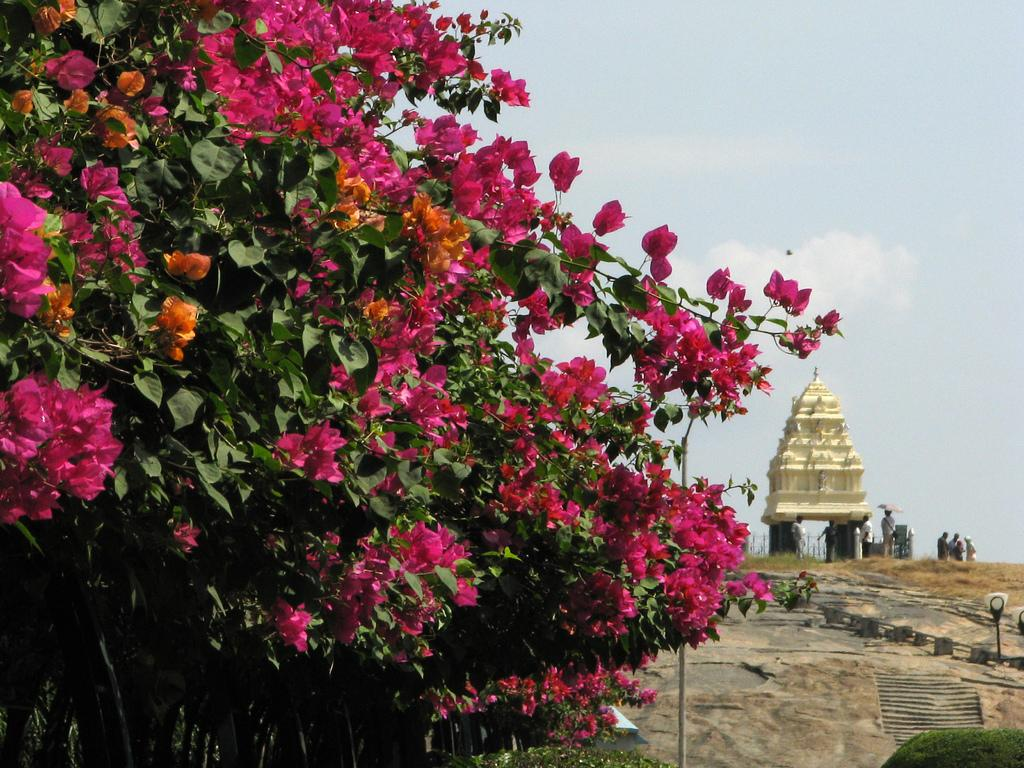What type of vegetation is present in the image? There are trees with flowers in the image. What type of structure can be seen on the right side of the image? There is a temple on the right side of the image. Can you describe the people in the image? There are people in the image, but their specific actions or appearances are not mentioned in the provided facts. What architectural feature is present in the image? There are stairs in the image. What else can be seen in the image besides the trees and temple? There are poles and plants in the image. What part of the natural environment is visible in the image? The sky is visible in the image. What type of belief system is being practiced in space in the image? There is no reference to space or any belief system being practiced in the image. The image features trees, a temple, people, stairs, poles, plants, and the sky. 